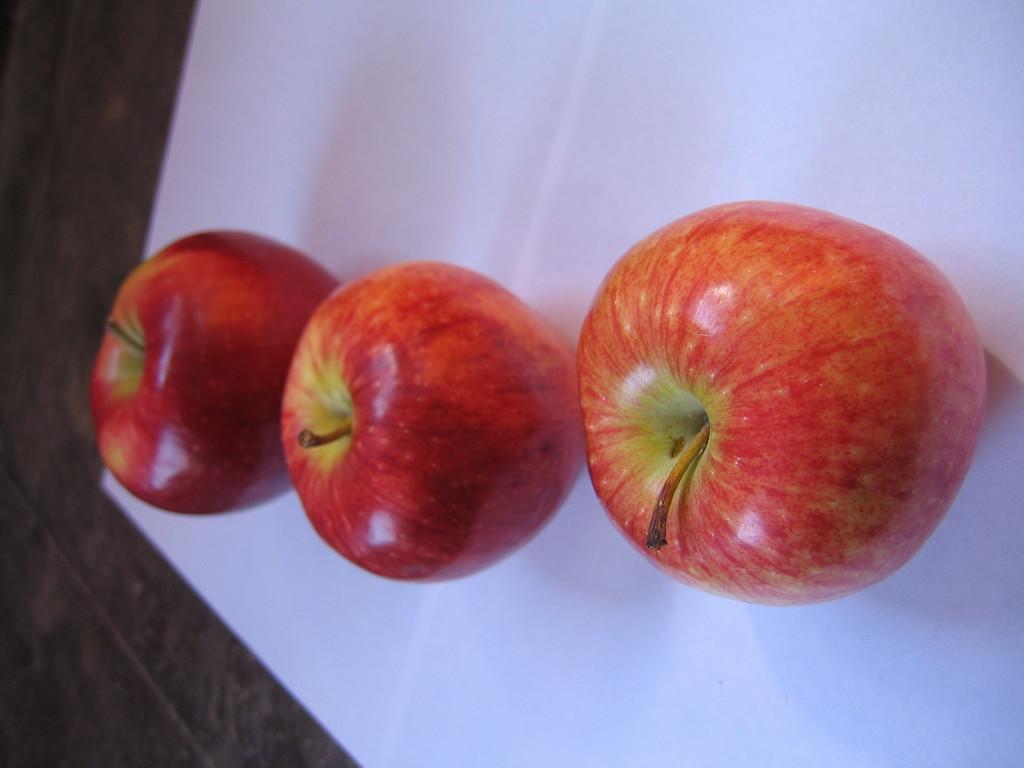In one or two sentences, can you explain what this image depicts? This image consists of fruits which are on the surface which is white in colour.. 